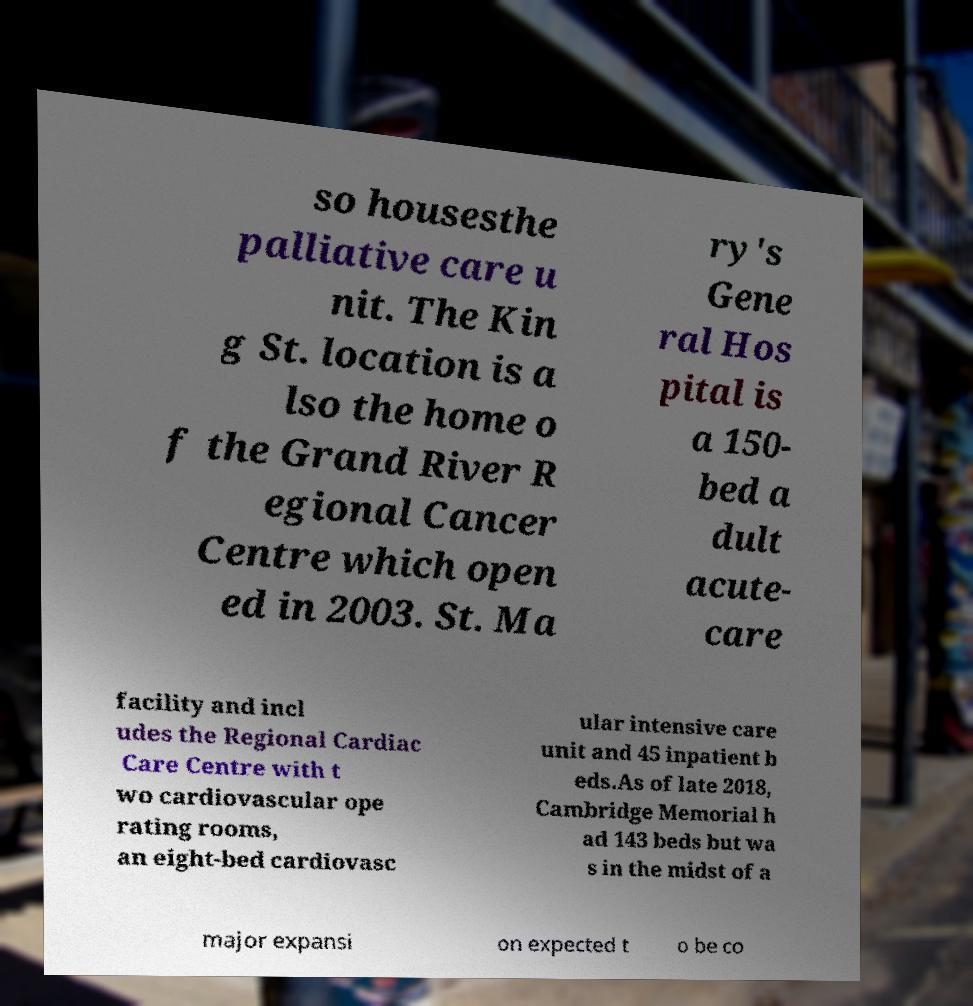Can you accurately transcribe the text from the provided image for me? so housesthe palliative care u nit. The Kin g St. location is a lso the home o f the Grand River R egional Cancer Centre which open ed in 2003. St. Ma ry's Gene ral Hos pital is a 150- bed a dult acute- care facility and incl udes the Regional Cardiac Care Centre with t wo cardiovascular ope rating rooms, an eight-bed cardiovasc ular intensive care unit and 45 inpatient b eds.As of late 2018, Cambridge Memorial h ad 143 beds but wa s in the midst of a major expansi on expected t o be co 